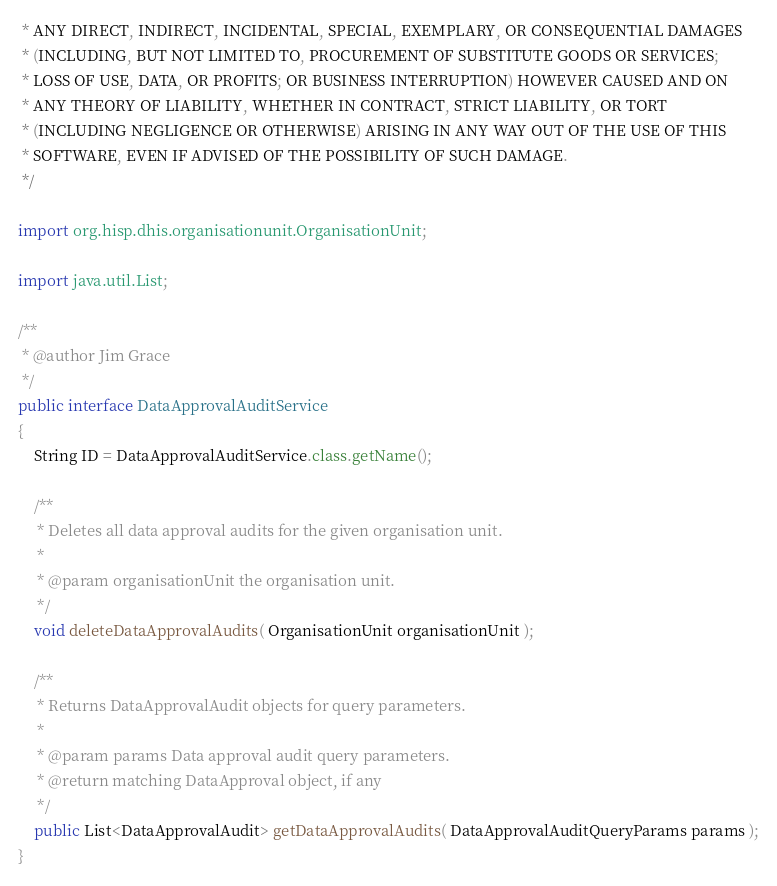Convert code to text. <code><loc_0><loc_0><loc_500><loc_500><_Java_> * ANY DIRECT, INDIRECT, INCIDENTAL, SPECIAL, EXEMPLARY, OR CONSEQUENTIAL DAMAGES
 * (INCLUDING, BUT NOT LIMITED TO, PROCUREMENT OF SUBSTITUTE GOODS OR SERVICES;
 * LOSS OF USE, DATA, OR PROFITS; OR BUSINESS INTERRUPTION) HOWEVER CAUSED AND ON
 * ANY THEORY OF LIABILITY, WHETHER IN CONTRACT, STRICT LIABILITY, OR TORT
 * (INCLUDING NEGLIGENCE OR OTHERWISE) ARISING IN ANY WAY OUT OF THE USE OF THIS
 * SOFTWARE, EVEN IF ADVISED OF THE POSSIBILITY OF SUCH DAMAGE.
 */

import org.hisp.dhis.organisationunit.OrganisationUnit;

import java.util.List;

/**
 * @author Jim Grace
 */
public interface DataApprovalAuditService
{
    String ID = DataApprovalAuditService.class.getName();

    /**
     * Deletes all data approval audits for the given organisation unit.
     *
     * @param organisationUnit the organisation unit.
     */
    void deleteDataApprovalAudits( OrganisationUnit organisationUnit );

    /**
     * Returns DataApprovalAudit objects for query parameters.
     *
     * @param params Data approval audit query parameters.
     * @return matching DataApproval object, if any
     */
    public List<DataApprovalAudit> getDataApprovalAudits( DataApprovalAuditQueryParams params );
}
</code> 